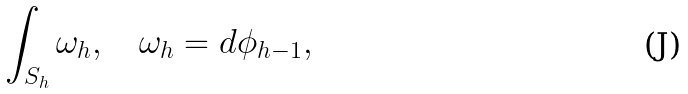Convert formula to latex. <formula><loc_0><loc_0><loc_500><loc_500>\int _ { S _ { h } } \omega _ { h } , \quad \omega _ { h } = d \phi _ { h - 1 } ,</formula> 